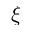<formula> <loc_0><loc_0><loc_500><loc_500>\xi</formula> 